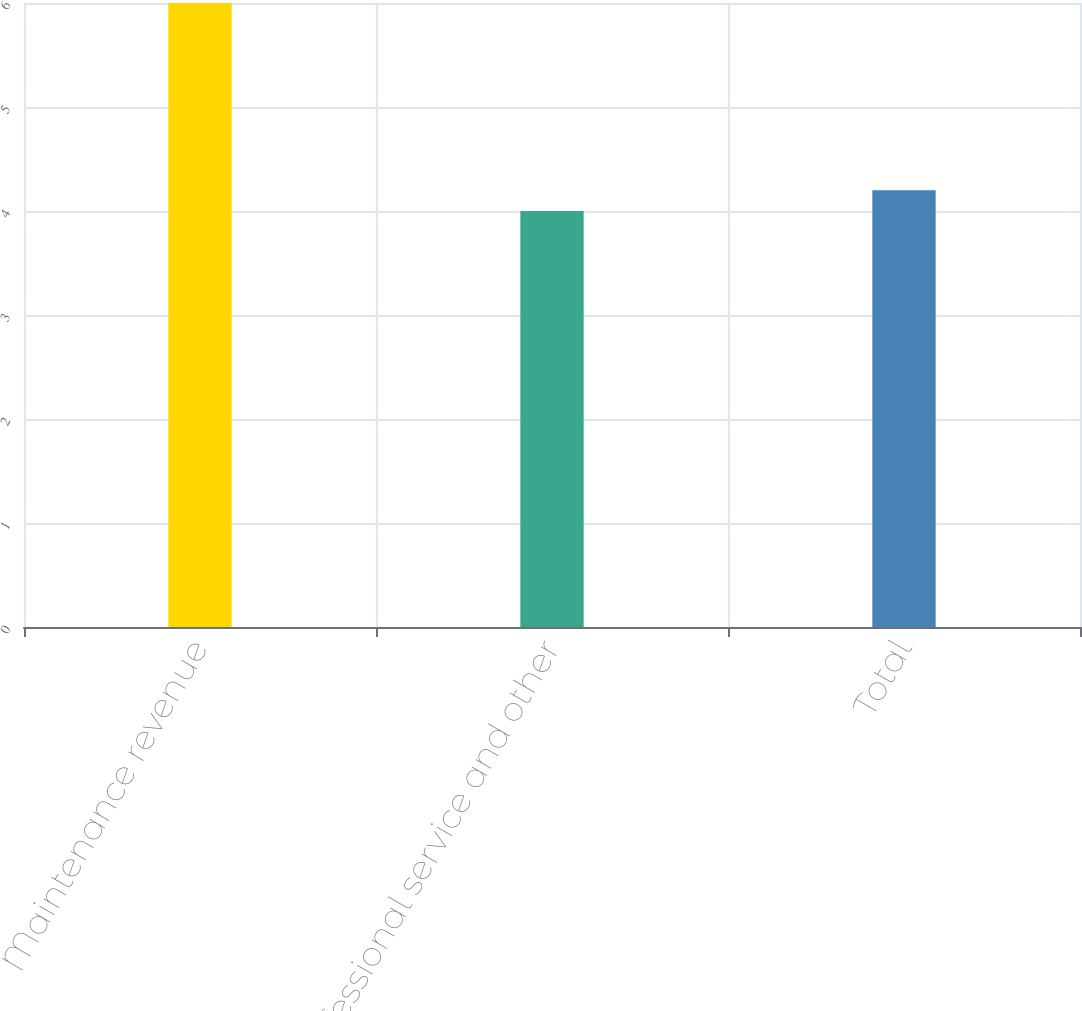<chart> <loc_0><loc_0><loc_500><loc_500><bar_chart><fcel>Maintenance revenue<fcel>Professional service and other<fcel>Total<nl><fcel>6<fcel>4<fcel>4.2<nl></chart> 